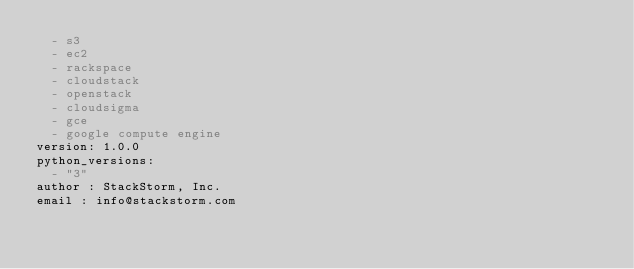Convert code to text. <code><loc_0><loc_0><loc_500><loc_500><_YAML_>  - s3
  - ec2
  - rackspace
  - cloudstack
  - openstack
  - cloudsigma
  - gce
  - google compute engine
version: 1.0.0
python_versions:
  - "3"
author : StackStorm, Inc.
email : info@stackstorm.com
</code> 